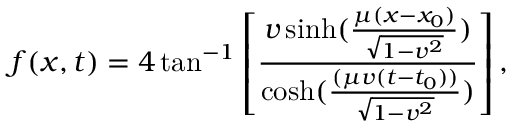<formula> <loc_0><loc_0><loc_500><loc_500>f ( x , t ) = 4 \tan ^ { - 1 } \left [ \frac { v \sinh ( \frac { \mu ( x - x _ { 0 } ) } { \sqrt { 1 - v ^ { 2 } } } ) } { \cosh ( \frac { ( \mu v ( t - t _ { 0 } ) ) } { \sqrt { 1 - v ^ { 2 } } } ) } \right ] ,</formula> 